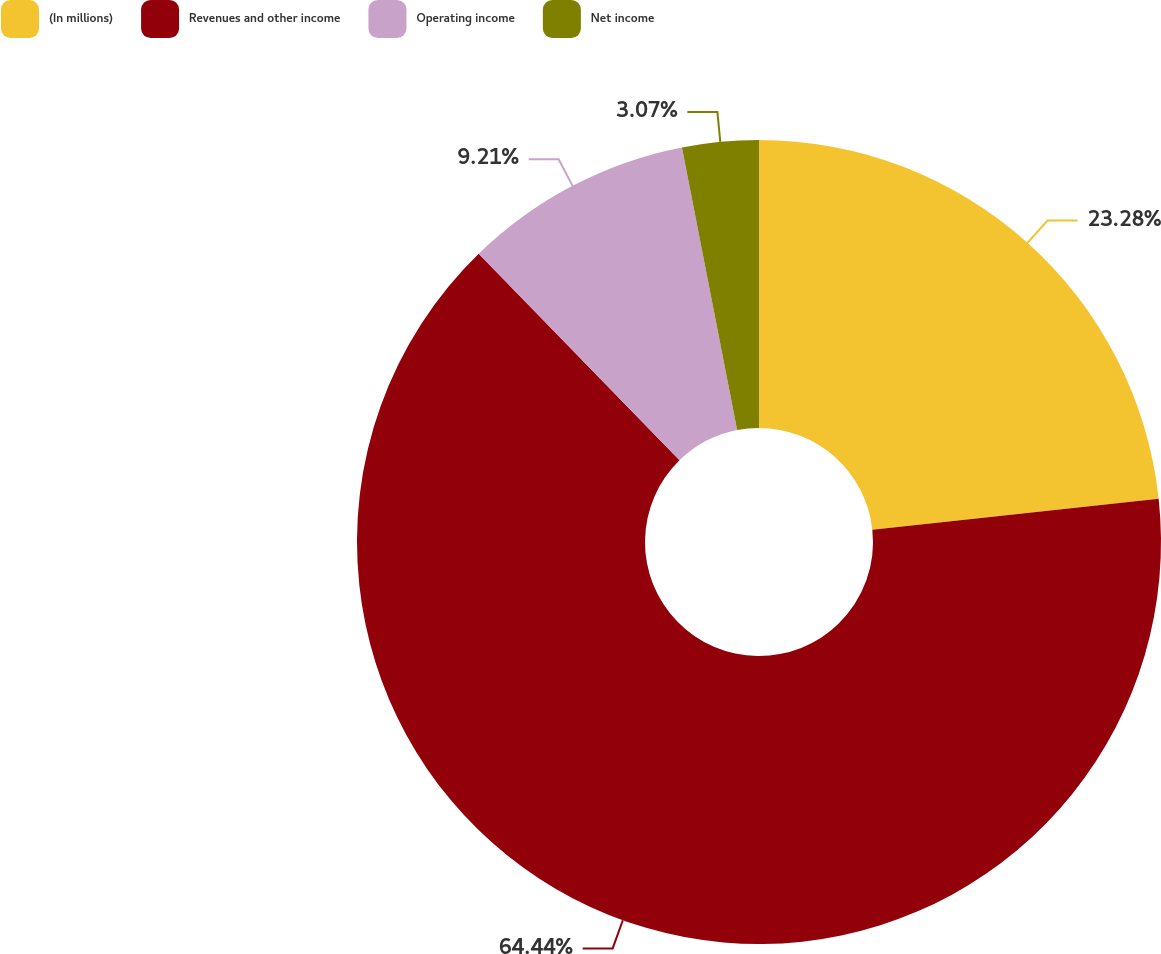Convert chart. <chart><loc_0><loc_0><loc_500><loc_500><pie_chart><fcel>(In millions)<fcel>Revenues and other income<fcel>Operating income<fcel>Net income<nl><fcel>23.28%<fcel>64.44%<fcel>9.21%<fcel>3.07%<nl></chart> 